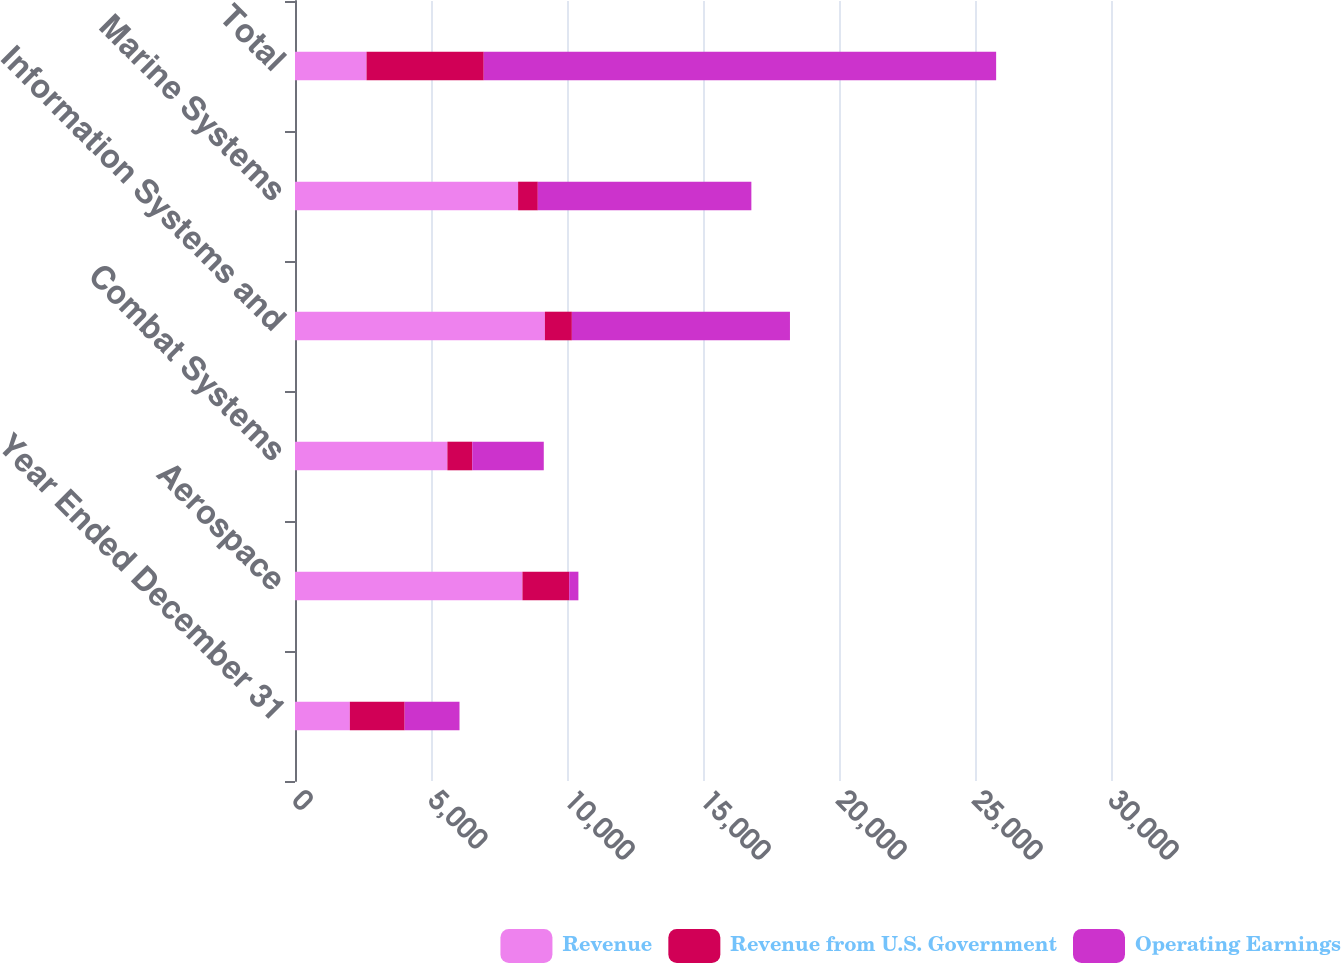<chart> <loc_0><loc_0><loc_500><loc_500><stacked_bar_chart><ecel><fcel>Year Ended December 31<fcel>Aerospace<fcel>Combat Systems<fcel>Information Systems and<fcel>Marine Systems<fcel>Total<nl><fcel>Revenue<fcel>2016<fcel>8362<fcel>5602<fcel>9187<fcel>8202<fcel>2630<nl><fcel>Revenue from U.S. Government<fcel>2016<fcel>1718<fcel>914<fcel>992<fcel>725<fcel>4309<nl><fcel>Operating Earnings<fcel>2016<fcel>339<fcel>2630<fcel>8018<fcel>7851<fcel>18838<nl></chart> 